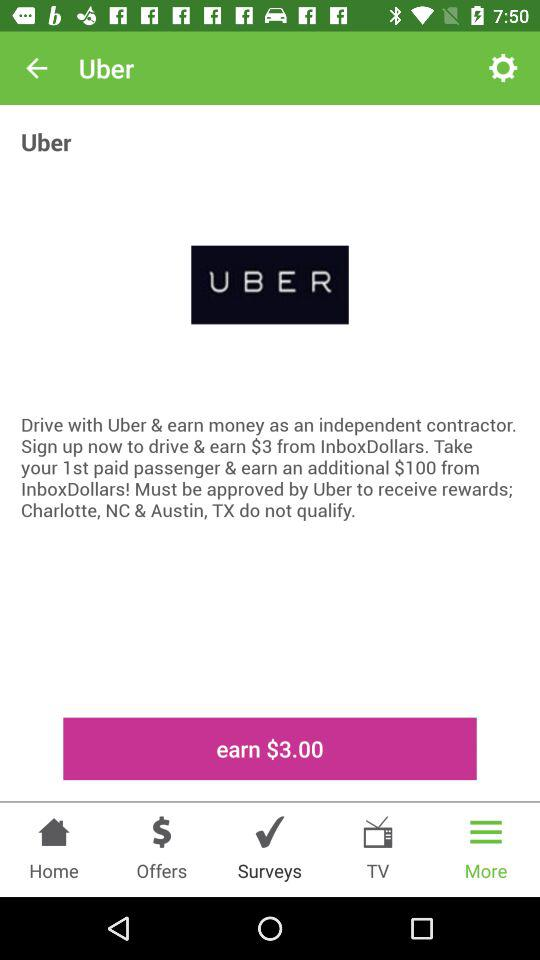How many more dollars can I earn by taking my first paid passenger?
Answer the question using a single word or phrase. $100 